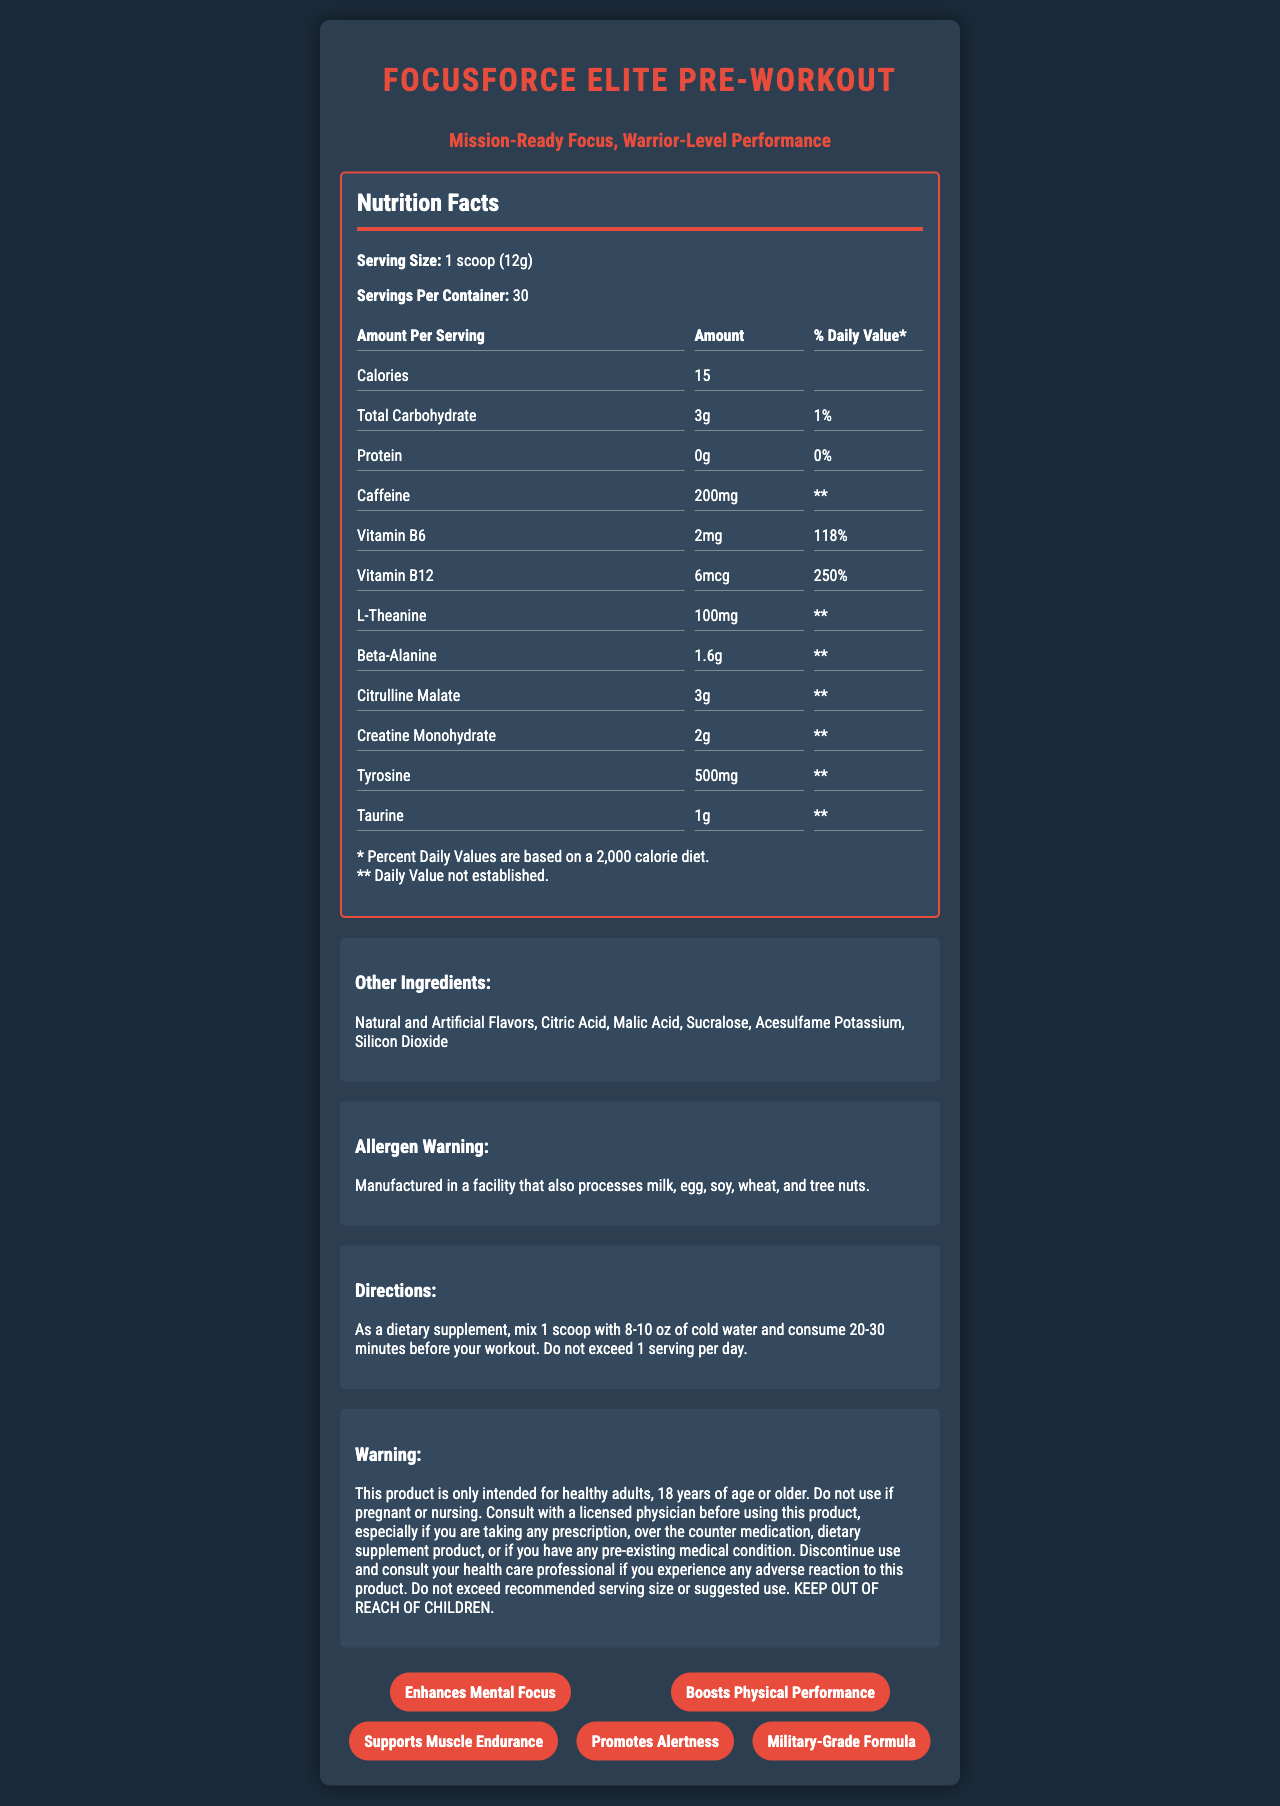what is the serving size of FocusForce Elite Pre-Workout? The serving size is explicitly mentioned at the top of the Nutrition Facts section.
Answer: 1 scoop (12g) how many servings are in each container? The document specifies "Servings Per Container: 30" right below the serving size.
Answer: 30 how many calories are there per serving? The calories per serving are clearly listed under the "Amount Per Serving" section.
Answer: 15 what is the amount of caffeine per serving? The amount of caffeine is listed with other nutrients under the "Amount Per Serving."
Answer: 200mg which ingredient is responsible for the high % daily value of Vitamin B6? The amount of Vitamin B6 is shown as 2mg, which corresponds to 118% of the daily value.
Answer: 2mg what is the purpose of the "Allergen Warning"? This warning is explicitly stated to caution consumers about potential allergen exposure.
Answer: To inform consumers that the product is manufactured in a facility that processes common allergens. how much protein is in each serving? The protein content is listed as 0g under the "Amount Per Serving."
Answer: 0g how should the supplement be consumed for best results? The directions for use are detailed under the "Directions" section.
Answer: Mix 1 scoop with 8-10 oz of cold water and consume 20-30 minutes before a workout. Do not exceed 1 serving per day. what is the main benefit of taking this supplement according to its marketing claims? A. Improves digestion B. Enhances mental focus C. Reduces stress Enhances mental focus is one of the main benefits claimed.
Answer: B which of the following ingredients are not listed under "Other Ingredients"? i. Sucralose ii. Calcium iii. Citric Acid iv. Vitamin E Calcium and Vitamin E are not listed under "Other Ingredients."
Answer: ii and iv is it safe to consume the supplement if you are pregnant? The warning statement clearly advises against using the product if pregnant or nursing.
Answer: No summarize the document The document provides comprehensive information about the pre-workout supplement, particularly its nutritional content, usage instructions, and safety warnings.
Answer: The document details the Nutrition Facts for FocusForce Elite Pre-Workout, featuring key ingredients and their amounts, serving size, and servings per container. It includes additional ingredient information, allergen warnings, consumption directions, and product warnings. The supplement claims to enhance mental focus and physical performance and is touted as a military-grade formula with a tagline "Mission-Ready Focus, Warrior-Level Performance." can we determine the country where the product is manufactured from the document? The document does not include any information about the manufacturing location of the product.
Answer: Not enough information 